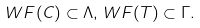Convert formula to latex. <formula><loc_0><loc_0><loc_500><loc_500>W F ( C ) \subset \Lambda , \, W F ( T ) \subset \Gamma .</formula> 